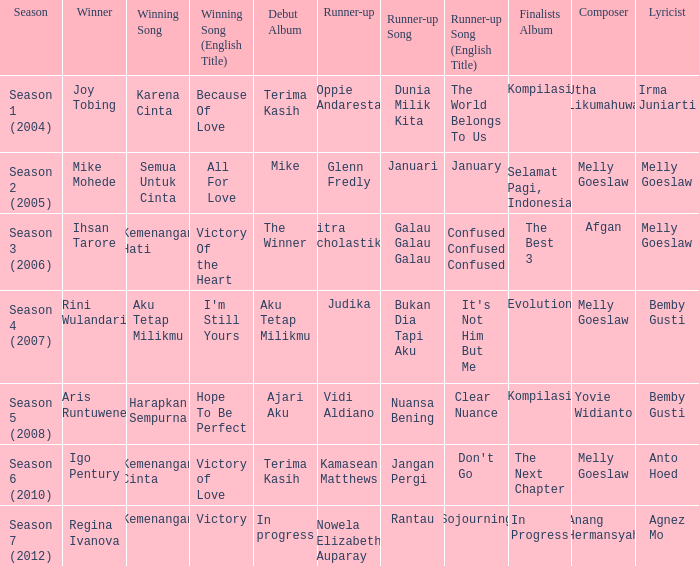Which winning song had a debut album in progress? Kemenangan. 